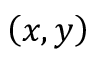Convert formula to latex. <formula><loc_0><loc_0><loc_500><loc_500>\left ( x , y \right )</formula> 